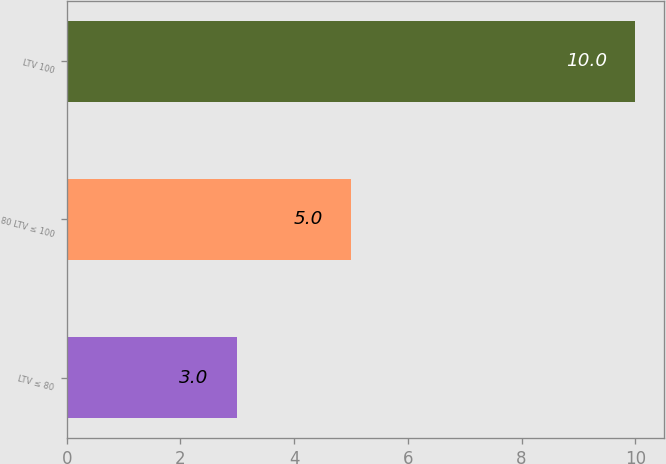Convert chart. <chart><loc_0><loc_0><loc_500><loc_500><bar_chart><fcel>LTV ≤ 80<fcel>80 LTV ≤ 100<fcel>LTV 100<nl><fcel>3<fcel>5<fcel>10<nl></chart> 